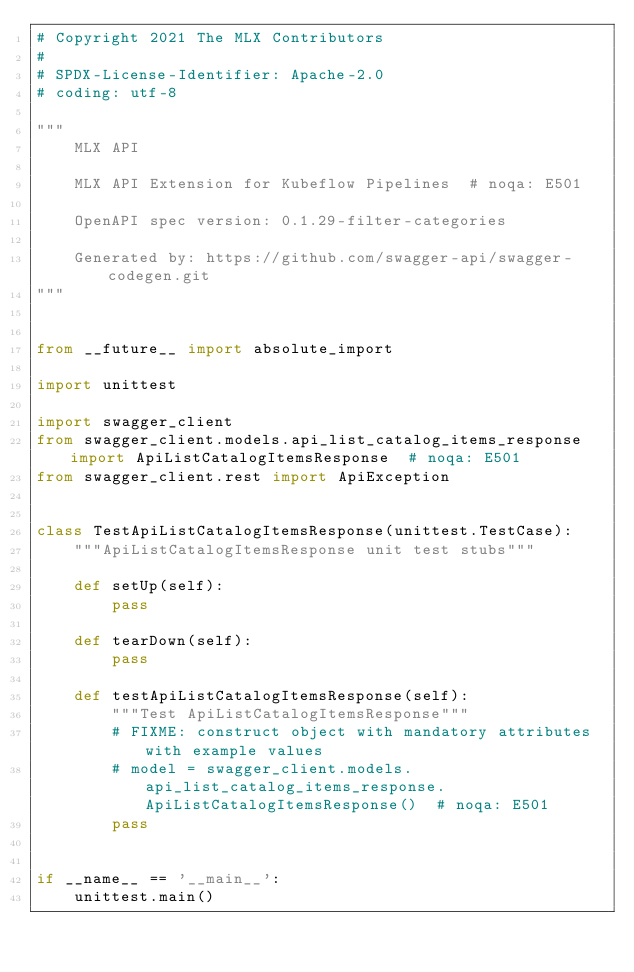<code> <loc_0><loc_0><loc_500><loc_500><_Python_># Copyright 2021 The MLX Contributors
#
# SPDX-License-Identifier: Apache-2.0
# coding: utf-8

"""
    MLX API

    MLX API Extension for Kubeflow Pipelines  # noqa: E501

    OpenAPI spec version: 0.1.29-filter-categories
    
    Generated by: https://github.com/swagger-api/swagger-codegen.git
"""


from __future__ import absolute_import

import unittest

import swagger_client
from swagger_client.models.api_list_catalog_items_response import ApiListCatalogItemsResponse  # noqa: E501
from swagger_client.rest import ApiException


class TestApiListCatalogItemsResponse(unittest.TestCase):
    """ApiListCatalogItemsResponse unit test stubs"""

    def setUp(self):
        pass

    def tearDown(self):
        pass

    def testApiListCatalogItemsResponse(self):
        """Test ApiListCatalogItemsResponse"""
        # FIXME: construct object with mandatory attributes with example values
        # model = swagger_client.models.api_list_catalog_items_response.ApiListCatalogItemsResponse()  # noqa: E501
        pass


if __name__ == '__main__':
    unittest.main()
</code> 